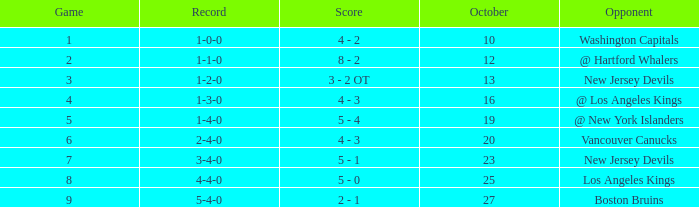Which game has the highest score in October with 9? 27.0. 